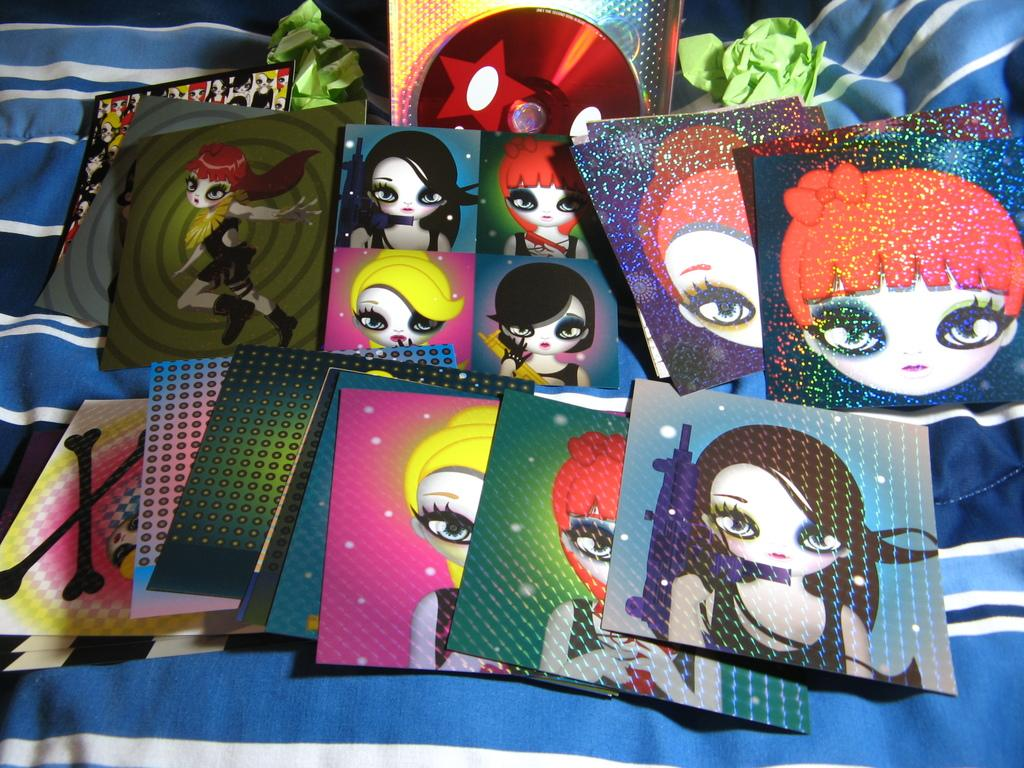What type of items can be seen in the image? There are cards with graphic images in the image. Can you describe the arrangement of the objects in the image? There are objects on a cloth in the image. What color is the sock worn by the achiever at the event in the image? There is no sock, achiever, or event present in the image. 